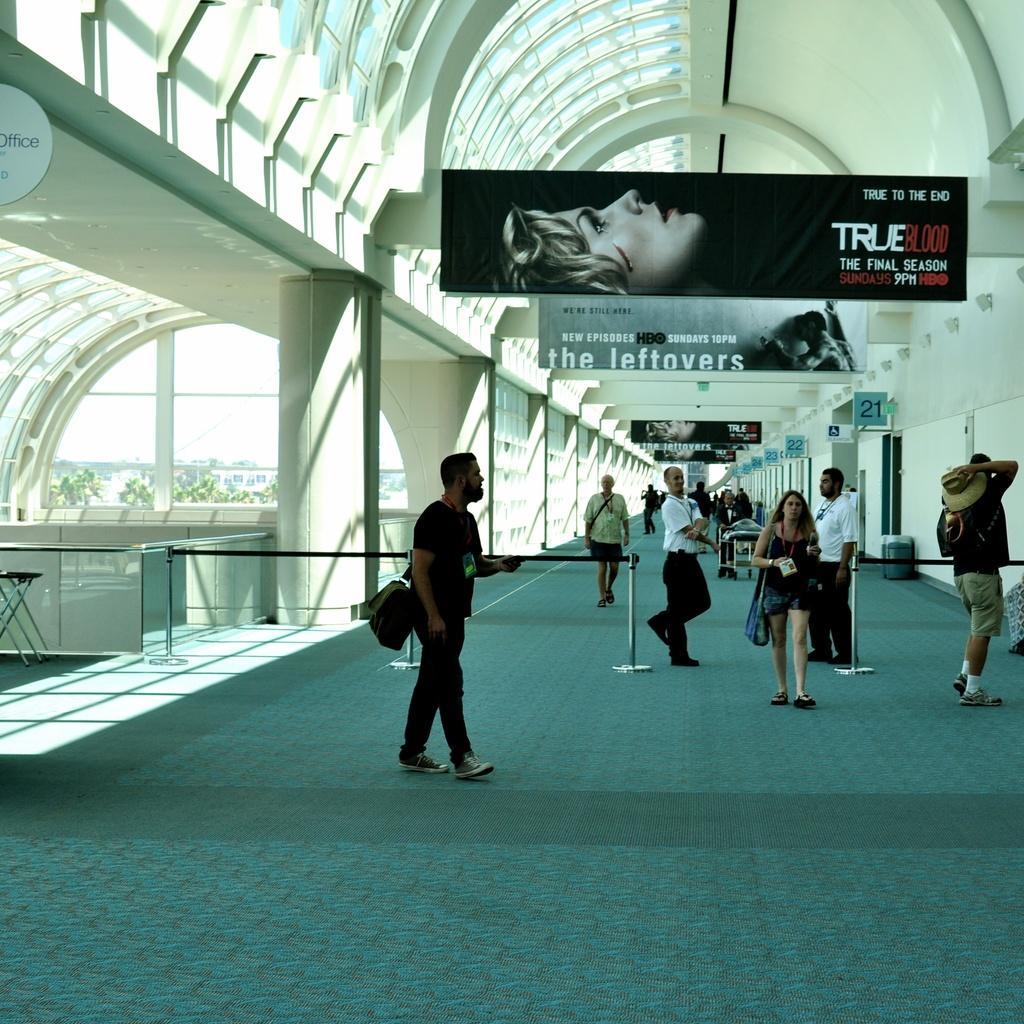Could you give a brief overview of what you see in this image? In this image there are persons standing and walking. On the top there are banners with some text written on it. On the left side there are walls and there are trees. On the right side there are boards with some numbers written on it and there are walls. 